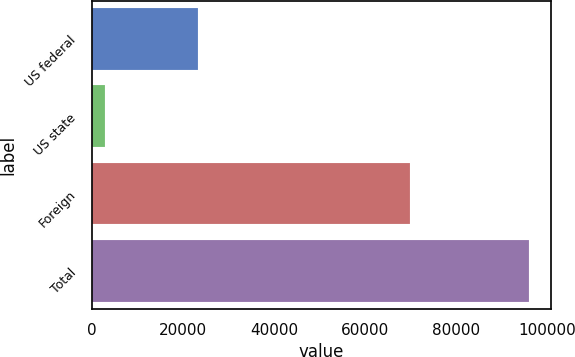Convert chart to OTSL. <chart><loc_0><loc_0><loc_500><loc_500><bar_chart><fcel>US federal<fcel>US state<fcel>Foreign<fcel>Total<nl><fcel>23412<fcel>2788<fcel>69954<fcel>96154<nl></chart> 